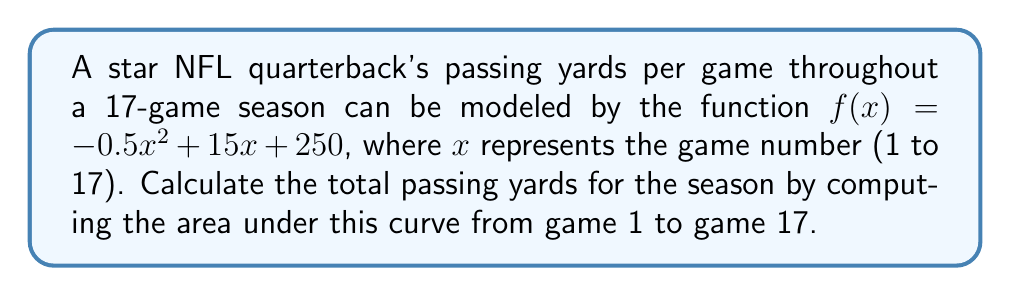What is the answer to this math problem? To solve this problem, we need to integrate the given function over the interval [1, 17]. Here's how we can approach it:

1) The function is $f(x) = -0.5x^2 + 15x + 250$

2) We need to find $$\int_1^{17} (-0.5x^2 + 15x + 250) dx$$

3) Let's integrate each term separately:
   
   $$\int (-0.5x^2) dx = -\frac{1}{6}x^3$$
   $$\int 15x dx = \frac{15}{2}x^2$$
   $$\int 250 dx = 250x$$

4) Now, let's apply the fundamental theorem of calculus:

   $$\left[-\frac{1}{6}x^3 + \frac{15}{2}x^2 + 250x\right]_1^{17}$$

5) Evaluate at the upper and lower bounds:

   $$\left(-\frac{1}{6}(17^3) + \frac{15}{2}(17^2) + 250(17)\right) - \left(-\frac{1}{6}(1^3) + \frac{15}{2}(1^2) + 250(1)\right)$$

6) Simplify:

   $$(-816.17 + 2167.5 + 4250) - (-0.17 + 7.5 + 250)$$
   
   $$5601.33 - 257.33 = 5344$$

7) Since we're calculating passing yards, we round to the nearest whole number.
Answer: The total passing yards for the season is approximately 5,344 yards. 